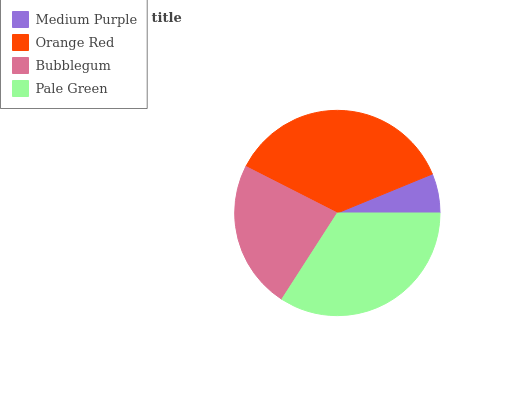Is Medium Purple the minimum?
Answer yes or no. Yes. Is Orange Red the maximum?
Answer yes or no. Yes. Is Bubblegum the minimum?
Answer yes or no. No. Is Bubblegum the maximum?
Answer yes or no. No. Is Orange Red greater than Bubblegum?
Answer yes or no. Yes. Is Bubblegum less than Orange Red?
Answer yes or no. Yes. Is Bubblegum greater than Orange Red?
Answer yes or no. No. Is Orange Red less than Bubblegum?
Answer yes or no. No. Is Pale Green the high median?
Answer yes or no. Yes. Is Bubblegum the low median?
Answer yes or no. Yes. Is Orange Red the high median?
Answer yes or no. No. Is Medium Purple the low median?
Answer yes or no. No. 